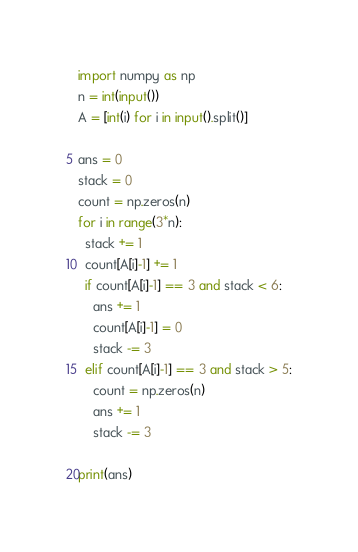<code> <loc_0><loc_0><loc_500><loc_500><_Python_>import numpy as np
n = int(input())
A = [int(i) for i in input().split()]

ans = 0
stack = 0
count = np.zeros(n)
for i in range(3*n):
  stack += 1
  count[A[i]-1] += 1
  if count[A[i]-1] == 3 and stack < 6:
    ans += 1
    count[A[i]-1] = 0 
    stack -= 3
  elif count[A[i]-1] == 3 and stack > 5:
    count = np.zeros(n)
    ans += 1
    stack -= 3
  
print(ans)</code> 